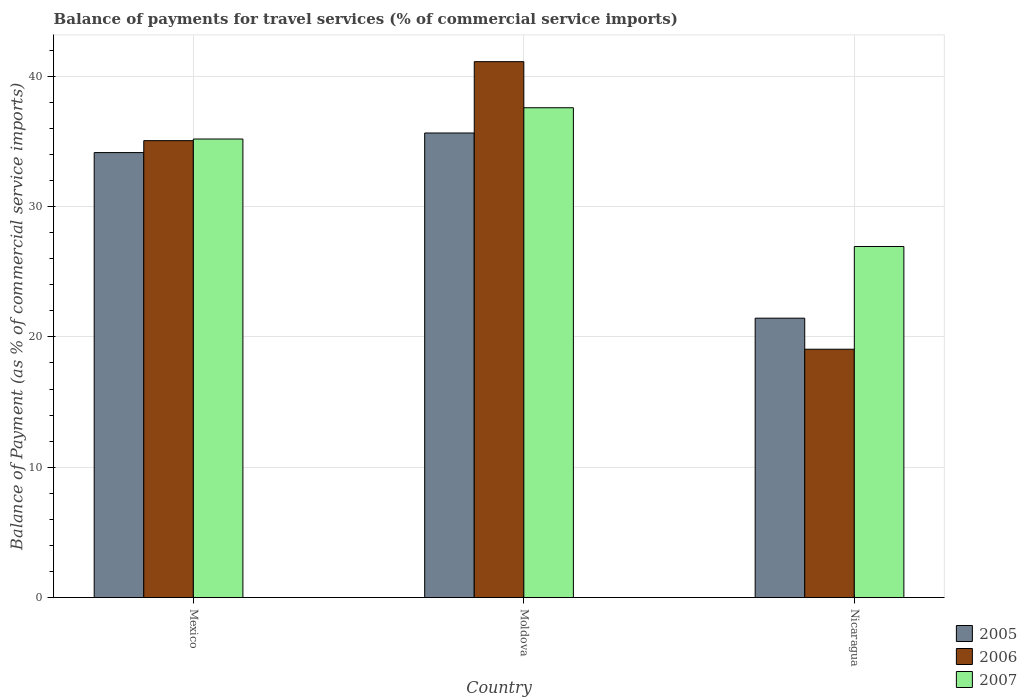How many groups of bars are there?
Keep it short and to the point. 3. Are the number of bars per tick equal to the number of legend labels?
Provide a short and direct response. Yes. In how many cases, is the number of bars for a given country not equal to the number of legend labels?
Make the answer very short. 0. What is the balance of payments for travel services in 2005 in Mexico?
Offer a terse response. 34.14. Across all countries, what is the maximum balance of payments for travel services in 2005?
Offer a terse response. 35.64. Across all countries, what is the minimum balance of payments for travel services in 2007?
Your answer should be compact. 26.94. In which country was the balance of payments for travel services in 2007 maximum?
Your answer should be compact. Moldova. In which country was the balance of payments for travel services in 2006 minimum?
Your response must be concise. Nicaragua. What is the total balance of payments for travel services in 2005 in the graph?
Keep it short and to the point. 91.22. What is the difference between the balance of payments for travel services in 2005 in Mexico and that in Moldova?
Provide a short and direct response. -1.5. What is the difference between the balance of payments for travel services in 2007 in Moldova and the balance of payments for travel services in 2006 in Mexico?
Your response must be concise. 2.53. What is the average balance of payments for travel services in 2007 per country?
Make the answer very short. 33.23. What is the difference between the balance of payments for travel services of/in 2006 and balance of payments for travel services of/in 2007 in Moldova?
Provide a short and direct response. 3.54. What is the ratio of the balance of payments for travel services in 2007 in Mexico to that in Moldova?
Make the answer very short. 0.94. Is the balance of payments for travel services in 2006 in Moldova less than that in Nicaragua?
Offer a terse response. No. What is the difference between the highest and the second highest balance of payments for travel services in 2006?
Your answer should be very brief. -22.06. What is the difference between the highest and the lowest balance of payments for travel services in 2007?
Ensure brevity in your answer.  10.65. In how many countries, is the balance of payments for travel services in 2006 greater than the average balance of payments for travel services in 2006 taken over all countries?
Your response must be concise. 2. Is the sum of the balance of payments for travel services in 2006 in Moldova and Nicaragua greater than the maximum balance of payments for travel services in 2007 across all countries?
Your answer should be very brief. Yes. Is it the case that in every country, the sum of the balance of payments for travel services in 2005 and balance of payments for travel services in 2007 is greater than the balance of payments for travel services in 2006?
Provide a short and direct response. Yes. How many bars are there?
Give a very brief answer. 9. Are all the bars in the graph horizontal?
Your answer should be compact. No. How many countries are there in the graph?
Provide a short and direct response. 3. Are the values on the major ticks of Y-axis written in scientific E-notation?
Keep it short and to the point. No. Does the graph contain any zero values?
Offer a terse response. No. How many legend labels are there?
Offer a very short reply. 3. What is the title of the graph?
Keep it short and to the point. Balance of payments for travel services (% of commercial service imports). What is the label or title of the Y-axis?
Ensure brevity in your answer.  Balance of Payment (as % of commercial service imports). What is the Balance of Payment (as % of commercial service imports) in 2005 in Mexico?
Offer a very short reply. 34.14. What is the Balance of Payment (as % of commercial service imports) in 2006 in Mexico?
Ensure brevity in your answer.  35.06. What is the Balance of Payment (as % of commercial service imports) in 2007 in Mexico?
Give a very brief answer. 35.18. What is the Balance of Payment (as % of commercial service imports) in 2005 in Moldova?
Offer a very short reply. 35.64. What is the Balance of Payment (as % of commercial service imports) of 2006 in Moldova?
Offer a very short reply. 41.12. What is the Balance of Payment (as % of commercial service imports) of 2007 in Moldova?
Offer a very short reply. 37.58. What is the Balance of Payment (as % of commercial service imports) of 2005 in Nicaragua?
Your answer should be very brief. 21.44. What is the Balance of Payment (as % of commercial service imports) of 2006 in Nicaragua?
Provide a succinct answer. 19.05. What is the Balance of Payment (as % of commercial service imports) of 2007 in Nicaragua?
Keep it short and to the point. 26.94. Across all countries, what is the maximum Balance of Payment (as % of commercial service imports) of 2005?
Provide a short and direct response. 35.64. Across all countries, what is the maximum Balance of Payment (as % of commercial service imports) of 2006?
Give a very brief answer. 41.12. Across all countries, what is the maximum Balance of Payment (as % of commercial service imports) in 2007?
Your response must be concise. 37.58. Across all countries, what is the minimum Balance of Payment (as % of commercial service imports) of 2005?
Make the answer very short. 21.44. Across all countries, what is the minimum Balance of Payment (as % of commercial service imports) in 2006?
Keep it short and to the point. 19.05. Across all countries, what is the minimum Balance of Payment (as % of commercial service imports) in 2007?
Ensure brevity in your answer.  26.94. What is the total Balance of Payment (as % of commercial service imports) in 2005 in the graph?
Give a very brief answer. 91.22. What is the total Balance of Payment (as % of commercial service imports) in 2006 in the graph?
Your answer should be compact. 95.23. What is the total Balance of Payment (as % of commercial service imports) of 2007 in the graph?
Your answer should be very brief. 99.7. What is the difference between the Balance of Payment (as % of commercial service imports) in 2005 in Mexico and that in Moldova?
Your response must be concise. -1.5. What is the difference between the Balance of Payment (as % of commercial service imports) of 2006 in Mexico and that in Moldova?
Offer a terse response. -6.06. What is the difference between the Balance of Payment (as % of commercial service imports) of 2007 in Mexico and that in Moldova?
Ensure brevity in your answer.  -2.4. What is the difference between the Balance of Payment (as % of commercial service imports) in 2005 in Mexico and that in Nicaragua?
Provide a succinct answer. 12.71. What is the difference between the Balance of Payment (as % of commercial service imports) in 2006 in Mexico and that in Nicaragua?
Ensure brevity in your answer.  16. What is the difference between the Balance of Payment (as % of commercial service imports) of 2007 in Mexico and that in Nicaragua?
Give a very brief answer. 8.25. What is the difference between the Balance of Payment (as % of commercial service imports) in 2005 in Moldova and that in Nicaragua?
Offer a very short reply. 14.21. What is the difference between the Balance of Payment (as % of commercial service imports) in 2006 in Moldova and that in Nicaragua?
Make the answer very short. 22.06. What is the difference between the Balance of Payment (as % of commercial service imports) in 2007 in Moldova and that in Nicaragua?
Provide a succinct answer. 10.65. What is the difference between the Balance of Payment (as % of commercial service imports) in 2005 in Mexico and the Balance of Payment (as % of commercial service imports) in 2006 in Moldova?
Keep it short and to the point. -6.98. What is the difference between the Balance of Payment (as % of commercial service imports) in 2005 in Mexico and the Balance of Payment (as % of commercial service imports) in 2007 in Moldova?
Offer a terse response. -3.44. What is the difference between the Balance of Payment (as % of commercial service imports) in 2006 in Mexico and the Balance of Payment (as % of commercial service imports) in 2007 in Moldova?
Give a very brief answer. -2.53. What is the difference between the Balance of Payment (as % of commercial service imports) in 2005 in Mexico and the Balance of Payment (as % of commercial service imports) in 2006 in Nicaragua?
Your answer should be very brief. 15.09. What is the difference between the Balance of Payment (as % of commercial service imports) in 2005 in Mexico and the Balance of Payment (as % of commercial service imports) in 2007 in Nicaragua?
Ensure brevity in your answer.  7.21. What is the difference between the Balance of Payment (as % of commercial service imports) of 2006 in Mexico and the Balance of Payment (as % of commercial service imports) of 2007 in Nicaragua?
Keep it short and to the point. 8.12. What is the difference between the Balance of Payment (as % of commercial service imports) in 2005 in Moldova and the Balance of Payment (as % of commercial service imports) in 2006 in Nicaragua?
Your answer should be very brief. 16.59. What is the difference between the Balance of Payment (as % of commercial service imports) in 2005 in Moldova and the Balance of Payment (as % of commercial service imports) in 2007 in Nicaragua?
Keep it short and to the point. 8.71. What is the difference between the Balance of Payment (as % of commercial service imports) in 2006 in Moldova and the Balance of Payment (as % of commercial service imports) in 2007 in Nicaragua?
Provide a succinct answer. 14.18. What is the average Balance of Payment (as % of commercial service imports) of 2005 per country?
Give a very brief answer. 30.41. What is the average Balance of Payment (as % of commercial service imports) in 2006 per country?
Make the answer very short. 31.74. What is the average Balance of Payment (as % of commercial service imports) in 2007 per country?
Keep it short and to the point. 33.23. What is the difference between the Balance of Payment (as % of commercial service imports) in 2005 and Balance of Payment (as % of commercial service imports) in 2006 in Mexico?
Your answer should be compact. -0.92. What is the difference between the Balance of Payment (as % of commercial service imports) of 2005 and Balance of Payment (as % of commercial service imports) of 2007 in Mexico?
Give a very brief answer. -1.04. What is the difference between the Balance of Payment (as % of commercial service imports) of 2006 and Balance of Payment (as % of commercial service imports) of 2007 in Mexico?
Offer a very short reply. -0.12. What is the difference between the Balance of Payment (as % of commercial service imports) of 2005 and Balance of Payment (as % of commercial service imports) of 2006 in Moldova?
Offer a terse response. -5.47. What is the difference between the Balance of Payment (as % of commercial service imports) of 2005 and Balance of Payment (as % of commercial service imports) of 2007 in Moldova?
Ensure brevity in your answer.  -1.94. What is the difference between the Balance of Payment (as % of commercial service imports) of 2006 and Balance of Payment (as % of commercial service imports) of 2007 in Moldova?
Your answer should be compact. 3.54. What is the difference between the Balance of Payment (as % of commercial service imports) in 2005 and Balance of Payment (as % of commercial service imports) in 2006 in Nicaragua?
Your response must be concise. 2.38. What is the difference between the Balance of Payment (as % of commercial service imports) in 2006 and Balance of Payment (as % of commercial service imports) in 2007 in Nicaragua?
Offer a terse response. -7.88. What is the ratio of the Balance of Payment (as % of commercial service imports) of 2005 in Mexico to that in Moldova?
Provide a succinct answer. 0.96. What is the ratio of the Balance of Payment (as % of commercial service imports) in 2006 in Mexico to that in Moldova?
Make the answer very short. 0.85. What is the ratio of the Balance of Payment (as % of commercial service imports) of 2007 in Mexico to that in Moldova?
Your answer should be compact. 0.94. What is the ratio of the Balance of Payment (as % of commercial service imports) in 2005 in Mexico to that in Nicaragua?
Ensure brevity in your answer.  1.59. What is the ratio of the Balance of Payment (as % of commercial service imports) in 2006 in Mexico to that in Nicaragua?
Make the answer very short. 1.84. What is the ratio of the Balance of Payment (as % of commercial service imports) of 2007 in Mexico to that in Nicaragua?
Your answer should be compact. 1.31. What is the ratio of the Balance of Payment (as % of commercial service imports) of 2005 in Moldova to that in Nicaragua?
Your response must be concise. 1.66. What is the ratio of the Balance of Payment (as % of commercial service imports) of 2006 in Moldova to that in Nicaragua?
Your answer should be very brief. 2.16. What is the ratio of the Balance of Payment (as % of commercial service imports) of 2007 in Moldova to that in Nicaragua?
Keep it short and to the point. 1.4. What is the difference between the highest and the second highest Balance of Payment (as % of commercial service imports) of 2005?
Offer a terse response. 1.5. What is the difference between the highest and the second highest Balance of Payment (as % of commercial service imports) in 2006?
Provide a succinct answer. 6.06. What is the difference between the highest and the second highest Balance of Payment (as % of commercial service imports) in 2007?
Ensure brevity in your answer.  2.4. What is the difference between the highest and the lowest Balance of Payment (as % of commercial service imports) in 2005?
Make the answer very short. 14.21. What is the difference between the highest and the lowest Balance of Payment (as % of commercial service imports) in 2006?
Offer a terse response. 22.06. What is the difference between the highest and the lowest Balance of Payment (as % of commercial service imports) in 2007?
Give a very brief answer. 10.65. 